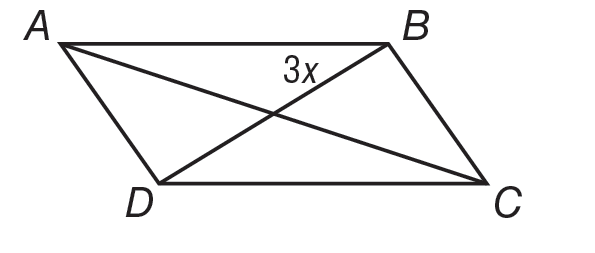Question: Quadrilateral A B C D is shown. A C is 40 and B D is \frac { 3 } { 5 } A C. B D bisects A C. For what value of x is A B C D a parallelogram.
Choices:
A. 0.6
B. 2.4
C. 4
D. 40
Answer with the letter. Answer: C 